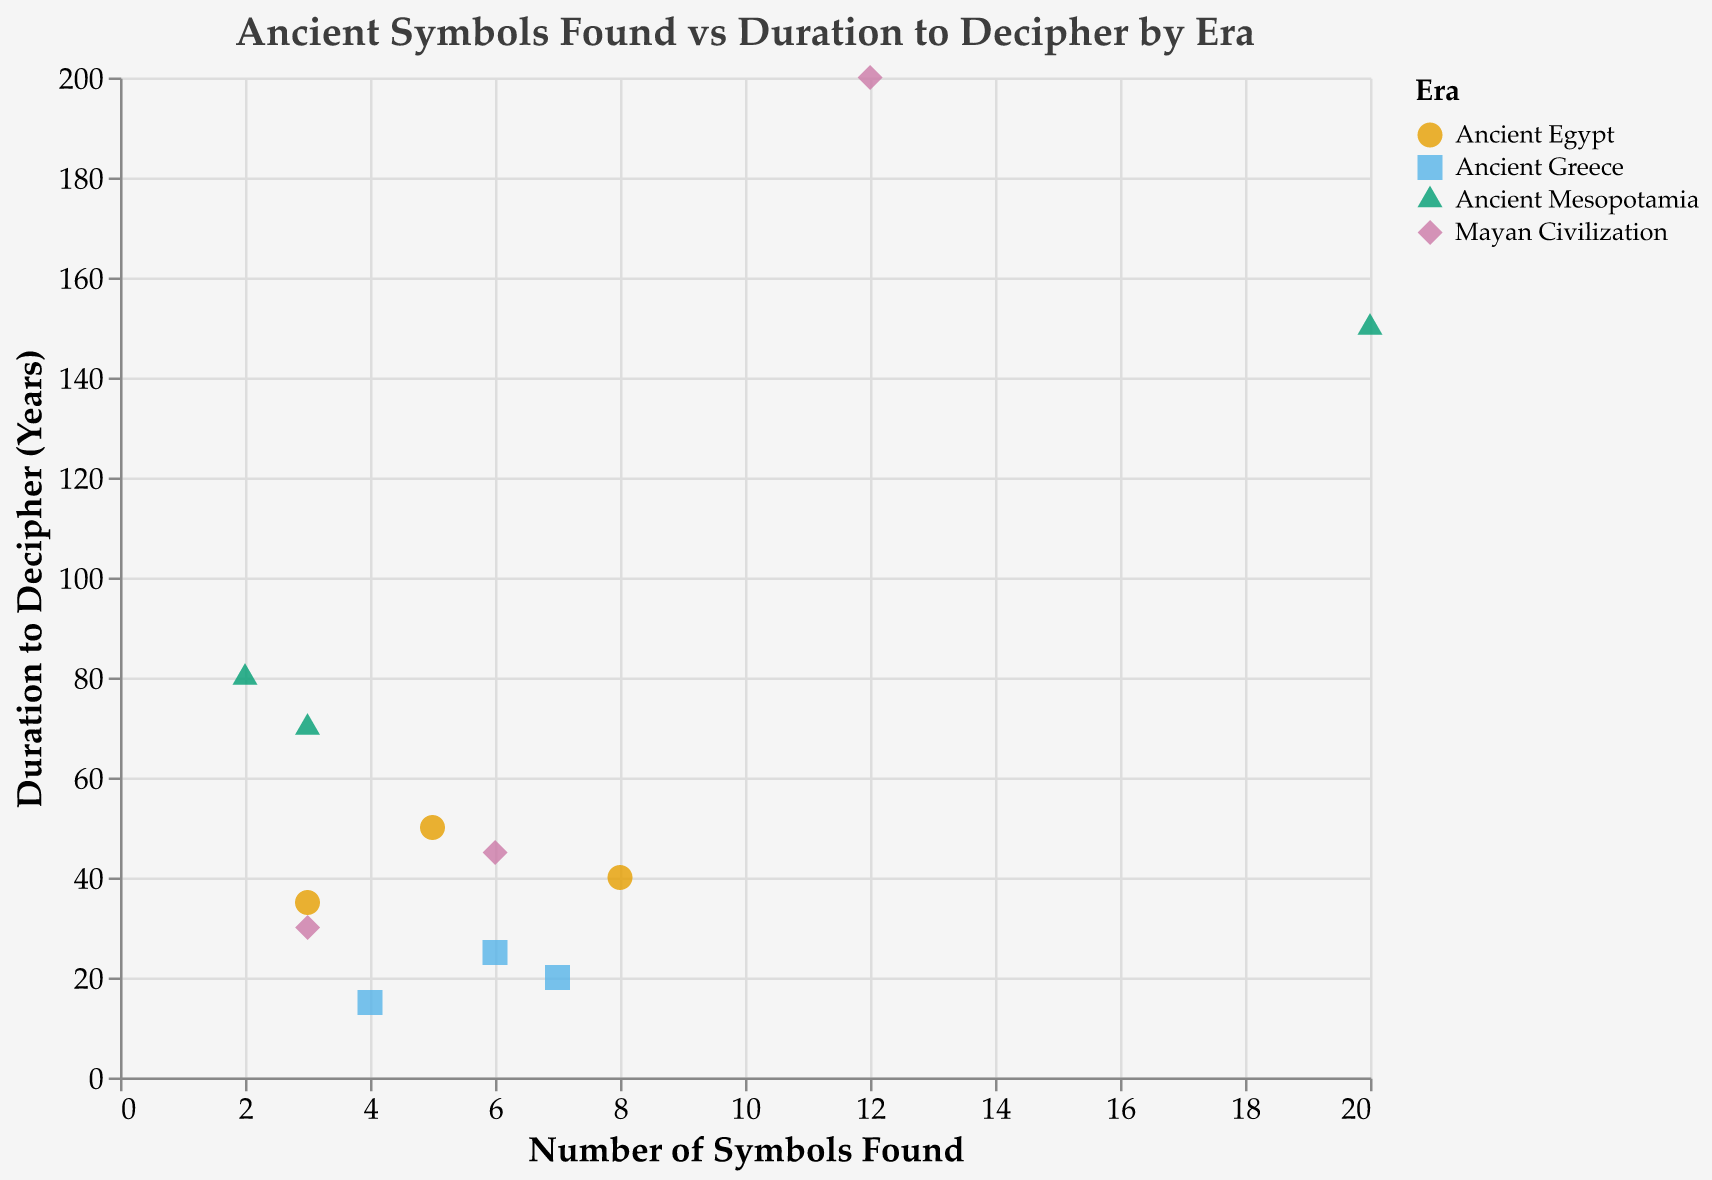What is the title of the plot? The title is displayed at the top of the figure with larger text. It reads "Ancient Symbols Found vs Duration to Decipher by Era"
Answer: Ancient Symbols Found vs Duration to Decipher by Era How many symbols are from the Ancient Greece era? We identify symbols marked with the color corresponding to Ancient Greece (#56B4E9, square). There are three symbols: Omega Symbol, Phoenix, and Lyra
Answer: 3 Which era has the symbol with the longest duration to decipher? The symbol with the longest duration to decipher is Calendar Glyphs (200 years), which is part of the Mayan Civilization
Answer: Mayan Civilization What is the range of "Symbols Found" in the Ancient Mesopotamia era? Look at symbols marked with the triangle shape for Ancient Mesopotamia. The "Symbols Found" values range from 2 (Bull of Heaven) to 20 (Cuneiform)
Answer: 2 to 20 Which symbol from the Mayan Civilization had the shortest duration to decipher? For symbols marked with the diamond shape for Mayan Civilization, the shortest duration is Feathered Serpent (30 years)
Answer: Feathered Serpent How many total symbols are represented in the plot? Count the symbols across all eras: 3 (Ancient Egypt) + 3 (Ancient Greece) + 3 (Ancient Mesopotamia) + 3 (Mayan Civilization) = 12
Answer: 12 What is the difference in deciphering duration between the symbol with the longest duration and the shortest duration? The longest duration is Calendar Glyphs (200 years), and the shortest is Phoenix (15 years). The difference is 200 - 15 = 185 years
Answer: 185 What is the trend in the duration to decipher symbols as the number of symbols found increases? Compare the plot points. Generally, there is no clear trend. For example, Mayan Civilization with many symbols (Calendar Glyphs) took the longest (200), while Ancient Greece's few symbols (Phoenix) took the shortest time (15)
Answer: No clear trend 